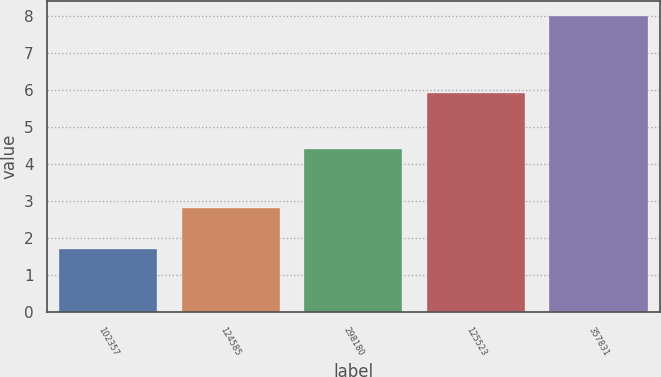<chart> <loc_0><loc_0><loc_500><loc_500><bar_chart><fcel>102357<fcel>124585<fcel>298180<fcel>125523<fcel>357831<nl><fcel>1.7<fcel>2.8<fcel>4.4<fcel>5.9<fcel>8<nl></chart> 